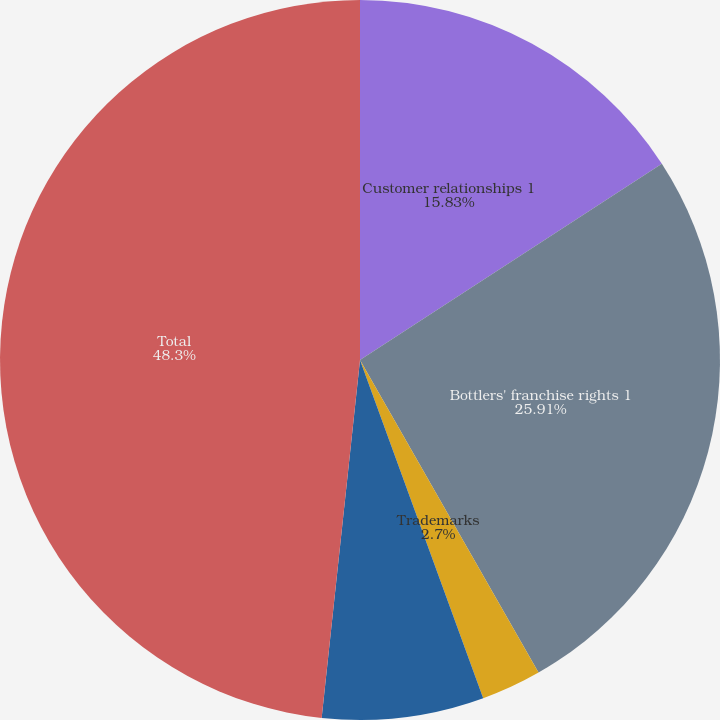<chart> <loc_0><loc_0><loc_500><loc_500><pie_chart><fcel>Customer relationships 1<fcel>Bottlers' franchise rights 1<fcel>Trademarks<fcel>Other<fcel>Total<nl><fcel>15.83%<fcel>25.92%<fcel>2.7%<fcel>7.26%<fcel>48.31%<nl></chart> 